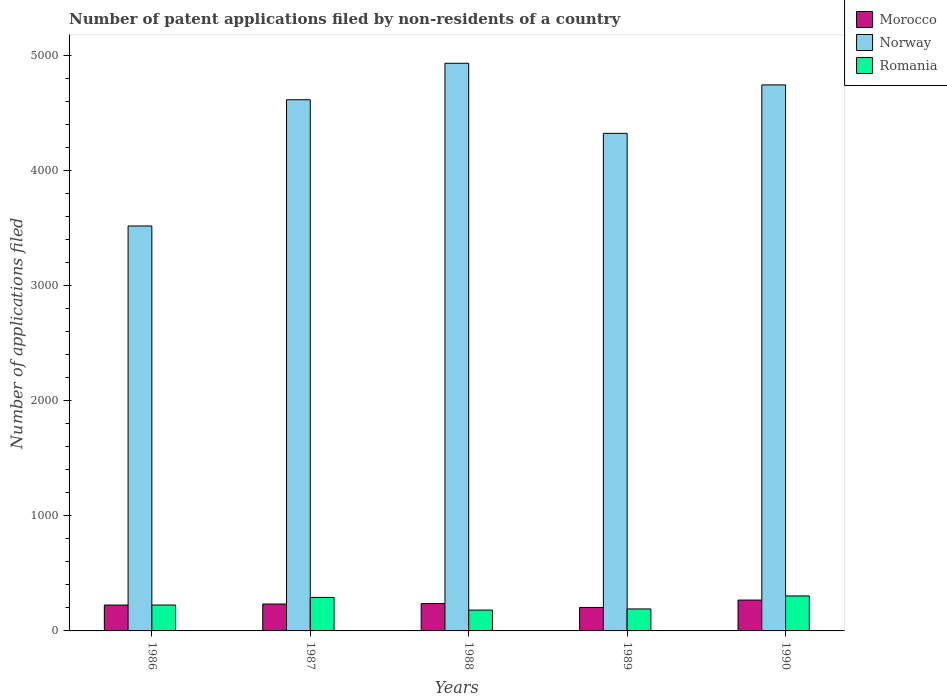How many different coloured bars are there?
Ensure brevity in your answer.  3. How many groups of bars are there?
Your response must be concise. 5. Are the number of bars on each tick of the X-axis equal?
Offer a terse response. Yes. In how many cases, is the number of bars for a given year not equal to the number of legend labels?
Give a very brief answer. 0. What is the number of applications filed in Romania in 1990?
Your answer should be very brief. 304. Across all years, what is the maximum number of applications filed in Norway?
Keep it short and to the point. 4933. Across all years, what is the minimum number of applications filed in Norway?
Your answer should be very brief. 3519. In which year was the number of applications filed in Morocco maximum?
Give a very brief answer. 1990. In which year was the number of applications filed in Norway minimum?
Provide a succinct answer. 1986. What is the total number of applications filed in Morocco in the graph?
Make the answer very short. 1169. What is the difference between the number of applications filed in Norway in 1987 and that in 1990?
Ensure brevity in your answer.  -129. What is the difference between the number of applications filed in Norway in 1988 and the number of applications filed in Morocco in 1989?
Make the answer very short. 4729. What is the average number of applications filed in Morocco per year?
Make the answer very short. 233.8. In the year 1987, what is the difference between the number of applications filed in Morocco and number of applications filed in Romania?
Give a very brief answer. -57. In how many years, is the number of applications filed in Romania greater than 4000?
Make the answer very short. 0. What is the ratio of the number of applications filed in Morocco in 1986 to that in 1988?
Your answer should be very brief. 0.95. Is the number of applications filed in Romania in 1986 less than that in 1989?
Make the answer very short. No. What is the difference between the highest and the lowest number of applications filed in Norway?
Your answer should be compact. 1414. In how many years, is the number of applications filed in Romania greater than the average number of applications filed in Romania taken over all years?
Provide a short and direct response. 2. Is the sum of the number of applications filed in Morocco in 1986 and 1990 greater than the maximum number of applications filed in Norway across all years?
Offer a very short reply. No. What does the 2nd bar from the left in 1988 represents?
Your answer should be very brief. Norway. What does the 1st bar from the right in 1986 represents?
Offer a terse response. Romania. Are all the bars in the graph horizontal?
Provide a succinct answer. No. How many years are there in the graph?
Your answer should be compact. 5. What is the difference between two consecutive major ticks on the Y-axis?
Keep it short and to the point. 1000. Are the values on the major ticks of Y-axis written in scientific E-notation?
Make the answer very short. No. Does the graph contain grids?
Ensure brevity in your answer.  No. Where does the legend appear in the graph?
Ensure brevity in your answer.  Top right. What is the title of the graph?
Provide a succinct answer. Number of patent applications filed by non-residents of a country. Does "Chile" appear as one of the legend labels in the graph?
Provide a short and direct response. No. What is the label or title of the Y-axis?
Offer a very short reply. Number of applications filed. What is the Number of applications filed of Morocco in 1986?
Ensure brevity in your answer.  225. What is the Number of applications filed in Norway in 1986?
Provide a short and direct response. 3519. What is the Number of applications filed of Romania in 1986?
Make the answer very short. 225. What is the Number of applications filed of Morocco in 1987?
Offer a terse response. 234. What is the Number of applications filed of Norway in 1987?
Offer a terse response. 4616. What is the Number of applications filed in Romania in 1987?
Provide a succinct answer. 291. What is the Number of applications filed of Morocco in 1988?
Provide a succinct answer. 238. What is the Number of applications filed of Norway in 1988?
Ensure brevity in your answer.  4933. What is the Number of applications filed in Romania in 1988?
Offer a very short reply. 181. What is the Number of applications filed of Morocco in 1989?
Your answer should be very brief. 204. What is the Number of applications filed in Norway in 1989?
Keep it short and to the point. 4324. What is the Number of applications filed of Romania in 1989?
Offer a terse response. 191. What is the Number of applications filed of Morocco in 1990?
Your response must be concise. 268. What is the Number of applications filed in Norway in 1990?
Provide a succinct answer. 4745. What is the Number of applications filed in Romania in 1990?
Offer a very short reply. 304. Across all years, what is the maximum Number of applications filed of Morocco?
Keep it short and to the point. 268. Across all years, what is the maximum Number of applications filed of Norway?
Provide a succinct answer. 4933. Across all years, what is the maximum Number of applications filed in Romania?
Make the answer very short. 304. Across all years, what is the minimum Number of applications filed in Morocco?
Your response must be concise. 204. Across all years, what is the minimum Number of applications filed in Norway?
Make the answer very short. 3519. Across all years, what is the minimum Number of applications filed in Romania?
Offer a very short reply. 181. What is the total Number of applications filed in Morocco in the graph?
Give a very brief answer. 1169. What is the total Number of applications filed in Norway in the graph?
Offer a very short reply. 2.21e+04. What is the total Number of applications filed of Romania in the graph?
Provide a succinct answer. 1192. What is the difference between the Number of applications filed in Norway in 1986 and that in 1987?
Provide a succinct answer. -1097. What is the difference between the Number of applications filed of Romania in 1986 and that in 1987?
Keep it short and to the point. -66. What is the difference between the Number of applications filed in Morocco in 1986 and that in 1988?
Give a very brief answer. -13. What is the difference between the Number of applications filed in Norway in 1986 and that in 1988?
Provide a succinct answer. -1414. What is the difference between the Number of applications filed of Romania in 1986 and that in 1988?
Make the answer very short. 44. What is the difference between the Number of applications filed of Morocco in 1986 and that in 1989?
Your response must be concise. 21. What is the difference between the Number of applications filed of Norway in 1986 and that in 1989?
Ensure brevity in your answer.  -805. What is the difference between the Number of applications filed of Romania in 1986 and that in 1989?
Provide a short and direct response. 34. What is the difference between the Number of applications filed in Morocco in 1986 and that in 1990?
Offer a terse response. -43. What is the difference between the Number of applications filed in Norway in 1986 and that in 1990?
Make the answer very short. -1226. What is the difference between the Number of applications filed of Romania in 1986 and that in 1990?
Provide a succinct answer. -79. What is the difference between the Number of applications filed in Morocco in 1987 and that in 1988?
Your answer should be very brief. -4. What is the difference between the Number of applications filed of Norway in 1987 and that in 1988?
Give a very brief answer. -317. What is the difference between the Number of applications filed in Romania in 1987 and that in 1988?
Make the answer very short. 110. What is the difference between the Number of applications filed of Norway in 1987 and that in 1989?
Make the answer very short. 292. What is the difference between the Number of applications filed in Romania in 1987 and that in 1989?
Your answer should be very brief. 100. What is the difference between the Number of applications filed of Morocco in 1987 and that in 1990?
Provide a short and direct response. -34. What is the difference between the Number of applications filed in Norway in 1987 and that in 1990?
Your answer should be very brief. -129. What is the difference between the Number of applications filed in Romania in 1987 and that in 1990?
Ensure brevity in your answer.  -13. What is the difference between the Number of applications filed of Morocco in 1988 and that in 1989?
Offer a terse response. 34. What is the difference between the Number of applications filed of Norway in 1988 and that in 1989?
Your response must be concise. 609. What is the difference between the Number of applications filed in Romania in 1988 and that in 1989?
Ensure brevity in your answer.  -10. What is the difference between the Number of applications filed of Norway in 1988 and that in 1990?
Your answer should be compact. 188. What is the difference between the Number of applications filed in Romania in 1988 and that in 1990?
Give a very brief answer. -123. What is the difference between the Number of applications filed in Morocco in 1989 and that in 1990?
Provide a succinct answer. -64. What is the difference between the Number of applications filed in Norway in 1989 and that in 1990?
Give a very brief answer. -421. What is the difference between the Number of applications filed in Romania in 1989 and that in 1990?
Provide a succinct answer. -113. What is the difference between the Number of applications filed of Morocco in 1986 and the Number of applications filed of Norway in 1987?
Provide a short and direct response. -4391. What is the difference between the Number of applications filed of Morocco in 1986 and the Number of applications filed of Romania in 1987?
Provide a short and direct response. -66. What is the difference between the Number of applications filed of Norway in 1986 and the Number of applications filed of Romania in 1987?
Make the answer very short. 3228. What is the difference between the Number of applications filed in Morocco in 1986 and the Number of applications filed in Norway in 1988?
Give a very brief answer. -4708. What is the difference between the Number of applications filed in Morocco in 1986 and the Number of applications filed in Romania in 1988?
Provide a short and direct response. 44. What is the difference between the Number of applications filed of Norway in 1986 and the Number of applications filed of Romania in 1988?
Ensure brevity in your answer.  3338. What is the difference between the Number of applications filed in Morocco in 1986 and the Number of applications filed in Norway in 1989?
Give a very brief answer. -4099. What is the difference between the Number of applications filed in Morocco in 1986 and the Number of applications filed in Romania in 1989?
Your answer should be compact. 34. What is the difference between the Number of applications filed in Norway in 1986 and the Number of applications filed in Romania in 1989?
Your answer should be very brief. 3328. What is the difference between the Number of applications filed of Morocco in 1986 and the Number of applications filed of Norway in 1990?
Your answer should be very brief. -4520. What is the difference between the Number of applications filed in Morocco in 1986 and the Number of applications filed in Romania in 1990?
Give a very brief answer. -79. What is the difference between the Number of applications filed of Norway in 1986 and the Number of applications filed of Romania in 1990?
Provide a short and direct response. 3215. What is the difference between the Number of applications filed in Morocco in 1987 and the Number of applications filed in Norway in 1988?
Provide a short and direct response. -4699. What is the difference between the Number of applications filed in Morocco in 1987 and the Number of applications filed in Romania in 1988?
Keep it short and to the point. 53. What is the difference between the Number of applications filed of Norway in 1987 and the Number of applications filed of Romania in 1988?
Provide a short and direct response. 4435. What is the difference between the Number of applications filed of Morocco in 1987 and the Number of applications filed of Norway in 1989?
Provide a short and direct response. -4090. What is the difference between the Number of applications filed in Norway in 1987 and the Number of applications filed in Romania in 1989?
Offer a very short reply. 4425. What is the difference between the Number of applications filed in Morocco in 1987 and the Number of applications filed in Norway in 1990?
Give a very brief answer. -4511. What is the difference between the Number of applications filed of Morocco in 1987 and the Number of applications filed of Romania in 1990?
Offer a very short reply. -70. What is the difference between the Number of applications filed of Norway in 1987 and the Number of applications filed of Romania in 1990?
Provide a short and direct response. 4312. What is the difference between the Number of applications filed of Morocco in 1988 and the Number of applications filed of Norway in 1989?
Your answer should be compact. -4086. What is the difference between the Number of applications filed in Norway in 1988 and the Number of applications filed in Romania in 1989?
Ensure brevity in your answer.  4742. What is the difference between the Number of applications filed in Morocco in 1988 and the Number of applications filed in Norway in 1990?
Keep it short and to the point. -4507. What is the difference between the Number of applications filed in Morocco in 1988 and the Number of applications filed in Romania in 1990?
Offer a terse response. -66. What is the difference between the Number of applications filed in Norway in 1988 and the Number of applications filed in Romania in 1990?
Offer a terse response. 4629. What is the difference between the Number of applications filed in Morocco in 1989 and the Number of applications filed in Norway in 1990?
Your answer should be very brief. -4541. What is the difference between the Number of applications filed in Morocco in 1989 and the Number of applications filed in Romania in 1990?
Provide a short and direct response. -100. What is the difference between the Number of applications filed in Norway in 1989 and the Number of applications filed in Romania in 1990?
Your answer should be very brief. 4020. What is the average Number of applications filed of Morocco per year?
Make the answer very short. 233.8. What is the average Number of applications filed in Norway per year?
Offer a very short reply. 4427.4. What is the average Number of applications filed in Romania per year?
Offer a terse response. 238.4. In the year 1986, what is the difference between the Number of applications filed of Morocco and Number of applications filed of Norway?
Your answer should be compact. -3294. In the year 1986, what is the difference between the Number of applications filed of Morocco and Number of applications filed of Romania?
Keep it short and to the point. 0. In the year 1986, what is the difference between the Number of applications filed of Norway and Number of applications filed of Romania?
Keep it short and to the point. 3294. In the year 1987, what is the difference between the Number of applications filed of Morocco and Number of applications filed of Norway?
Offer a very short reply. -4382. In the year 1987, what is the difference between the Number of applications filed of Morocco and Number of applications filed of Romania?
Your answer should be very brief. -57. In the year 1987, what is the difference between the Number of applications filed in Norway and Number of applications filed in Romania?
Provide a short and direct response. 4325. In the year 1988, what is the difference between the Number of applications filed in Morocco and Number of applications filed in Norway?
Offer a very short reply. -4695. In the year 1988, what is the difference between the Number of applications filed of Morocco and Number of applications filed of Romania?
Provide a succinct answer. 57. In the year 1988, what is the difference between the Number of applications filed in Norway and Number of applications filed in Romania?
Give a very brief answer. 4752. In the year 1989, what is the difference between the Number of applications filed in Morocco and Number of applications filed in Norway?
Your answer should be very brief. -4120. In the year 1989, what is the difference between the Number of applications filed of Norway and Number of applications filed of Romania?
Offer a very short reply. 4133. In the year 1990, what is the difference between the Number of applications filed of Morocco and Number of applications filed of Norway?
Your answer should be compact. -4477. In the year 1990, what is the difference between the Number of applications filed of Morocco and Number of applications filed of Romania?
Keep it short and to the point. -36. In the year 1990, what is the difference between the Number of applications filed in Norway and Number of applications filed in Romania?
Provide a succinct answer. 4441. What is the ratio of the Number of applications filed of Morocco in 1986 to that in 1987?
Your answer should be compact. 0.96. What is the ratio of the Number of applications filed of Norway in 1986 to that in 1987?
Your answer should be compact. 0.76. What is the ratio of the Number of applications filed of Romania in 1986 to that in 1987?
Keep it short and to the point. 0.77. What is the ratio of the Number of applications filed of Morocco in 1986 to that in 1988?
Give a very brief answer. 0.95. What is the ratio of the Number of applications filed of Norway in 1986 to that in 1988?
Make the answer very short. 0.71. What is the ratio of the Number of applications filed of Romania in 1986 to that in 1988?
Give a very brief answer. 1.24. What is the ratio of the Number of applications filed of Morocco in 1986 to that in 1989?
Provide a short and direct response. 1.1. What is the ratio of the Number of applications filed in Norway in 1986 to that in 1989?
Offer a very short reply. 0.81. What is the ratio of the Number of applications filed in Romania in 1986 to that in 1989?
Your response must be concise. 1.18. What is the ratio of the Number of applications filed of Morocco in 1986 to that in 1990?
Your answer should be compact. 0.84. What is the ratio of the Number of applications filed of Norway in 1986 to that in 1990?
Your answer should be very brief. 0.74. What is the ratio of the Number of applications filed of Romania in 1986 to that in 1990?
Ensure brevity in your answer.  0.74. What is the ratio of the Number of applications filed of Morocco in 1987 to that in 1988?
Your answer should be compact. 0.98. What is the ratio of the Number of applications filed in Norway in 1987 to that in 1988?
Your answer should be compact. 0.94. What is the ratio of the Number of applications filed in Romania in 1987 to that in 1988?
Provide a succinct answer. 1.61. What is the ratio of the Number of applications filed in Morocco in 1987 to that in 1989?
Provide a succinct answer. 1.15. What is the ratio of the Number of applications filed in Norway in 1987 to that in 1989?
Your response must be concise. 1.07. What is the ratio of the Number of applications filed in Romania in 1987 to that in 1989?
Offer a very short reply. 1.52. What is the ratio of the Number of applications filed of Morocco in 1987 to that in 1990?
Keep it short and to the point. 0.87. What is the ratio of the Number of applications filed of Norway in 1987 to that in 1990?
Offer a terse response. 0.97. What is the ratio of the Number of applications filed in Romania in 1987 to that in 1990?
Keep it short and to the point. 0.96. What is the ratio of the Number of applications filed in Morocco in 1988 to that in 1989?
Provide a short and direct response. 1.17. What is the ratio of the Number of applications filed of Norway in 1988 to that in 1989?
Your response must be concise. 1.14. What is the ratio of the Number of applications filed in Romania in 1988 to that in 1989?
Offer a terse response. 0.95. What is the ratio of the Number of applications filed in Morocco in 1988 to that in 1990?
Your answer should be very brief. 0.89. What is the ratio of the Number of applications filed in Norway in 1988 to that in 1990?
Ensure brevity in your answer.  1.04. What is the ratio of the Number of applications filed in Romania in 1988 to that in 1990?
Offer a terse response. 0.6. What is the ratio of the Number of applications filed of Morocco in 1989 to that in 1990?
Offer a terse response. 0.76. What is the ratio of the Number of applications filed of Norway in 1989 to that in 1990?
Make the answer very short. 0.91. What is the ratio of the Number of applications filed in Romania in 1989 to that in 1990?
Provide a short and direct response. 0.63. What is the difference between the highest and the second highest Number of applications filed in Norway?
Your answer should be compact. 188. What is the difference between the highest and the second highest Number of applications filed of Romania?
Your answer should be very brief. 13. What is the difference between the highest and the lowest Number of applications filed of Norway?
Provide a succinct answer. 1414. What is the difference between the highest and the lowest Number of applications filed in Romania?
Give a very brief answer. 123. 